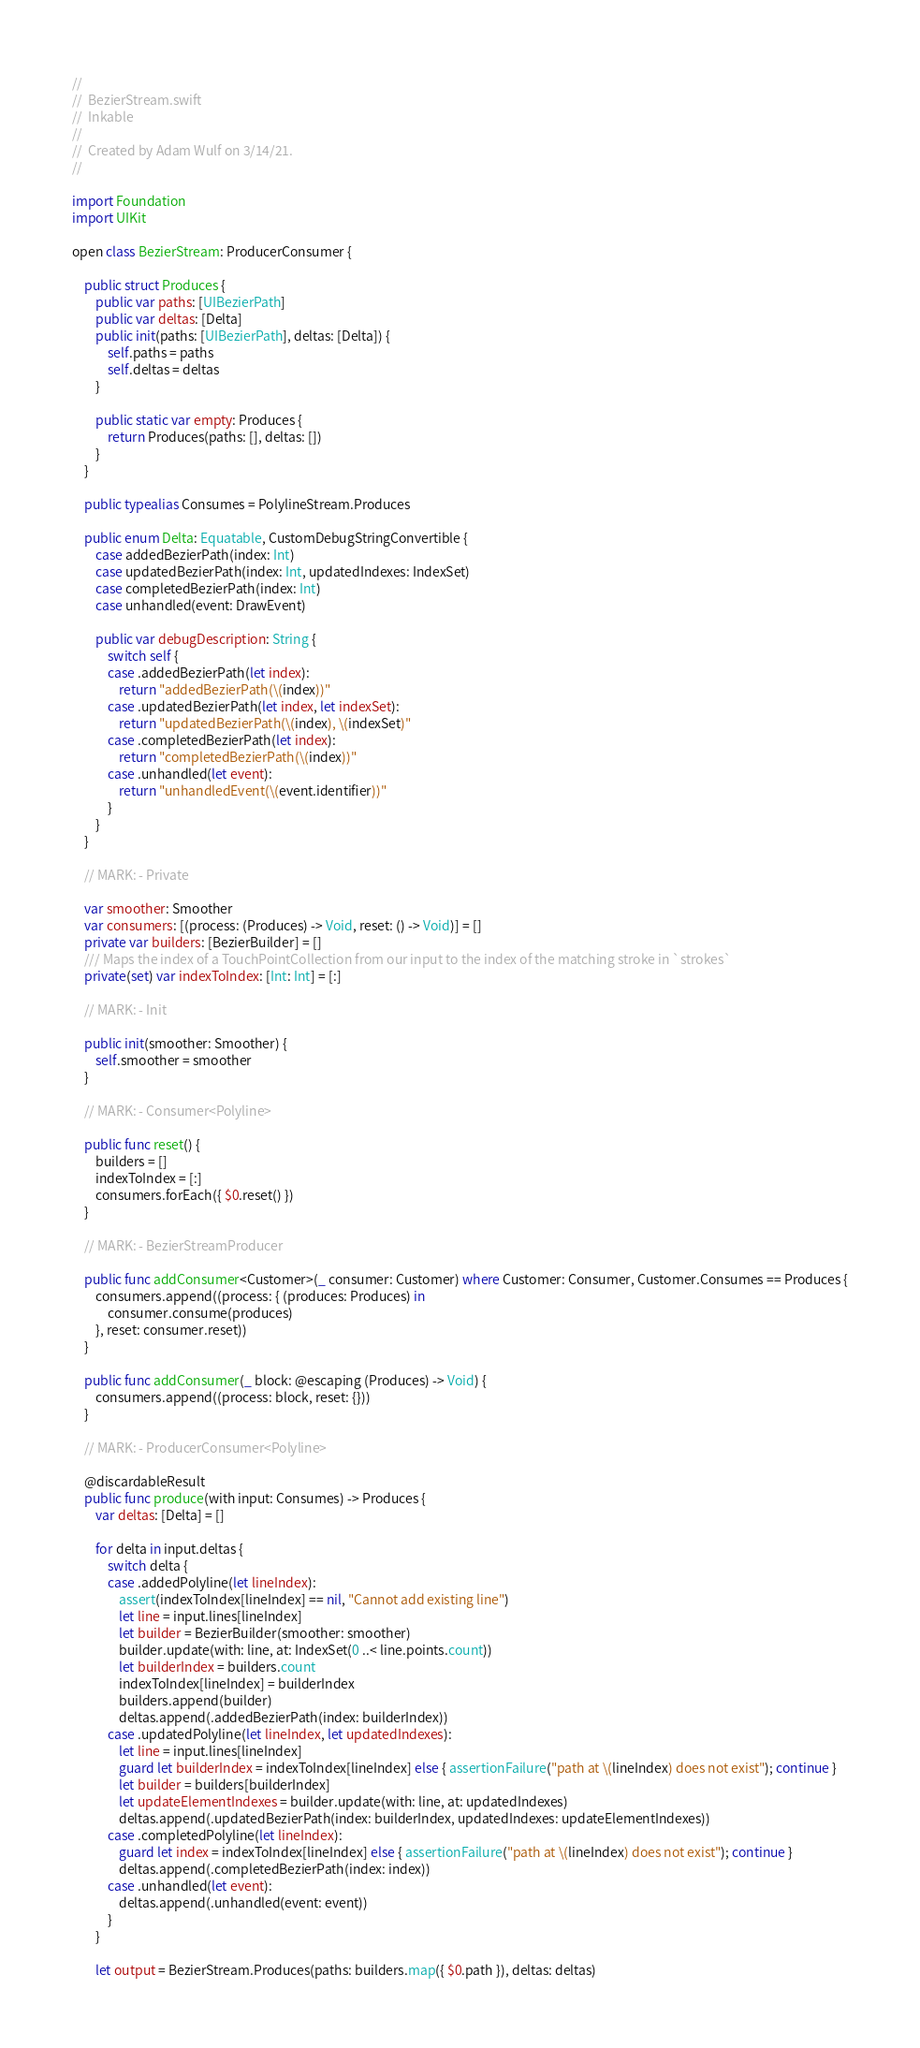<code> <loc_0><loc_0><loc_500><loc_500><_Swift_>//
//  BezierStream.swift
//  Inkable
//
//  Created by Adam Wulf on 3/14/21.
//

import Foundation
import UIKit

open class BezierStream: ProducerConsumer {

    public struct Produces {
        public var paths: [UIBezierPath]
        public var deltas: [Delta]
        public init(paths: [UIBezierPath], deltas: [Delta]) {
            self.paths = paths
            self.deltas = deltas
        }

        public static var empty: Produces {
            return Produces(paths: [], deltas: [])
        }
    }

    public typealias Consumes = PolylineStream.Produces

    public enum Delta: Equatable, CustomDebugStringConvertible {
        case addedBezierPath(index: Int)
        case updatedBezierPath(index: Int, updatedIndexes: IndexSet)
        case completedBezierPath(index: Int)
        case unhandled(event: DrawEvent)

        public var debugDescription: String {
            switch self {
            case .addedBezierPath(let index):
                return "addedBezierPath(\(index))"
            case .updatedBezierPath(let index, let indexSet):
                return "updatedBezierPath(\(index), \(indexSet)"
            case .completedBezierPath(let index):
                return "completedBezierPath(\(index))"
            case .unhandled(let event):
                return "unhandledEvent(\(event.identifier))"
            }
        }
    }

    // MARK: - Private

    var smoother: Smoother
    var consumers: [(process: (Produces) -> Void, reset: () -> Void)] = []
    private var builders: [BezierBuilder] = []
    /// Maps the index of a TouchPointCollection from our input to the index of the matching stroke in `strokes`
    private(set) var indexToIndex: [Int: Int] = [:]

    // MARK: - Init

    public init(smoother: Smoother) {
        self.smoother = smoother
    }

    // MARK: - Consumer<Polyline>

    public func reset() {
        builders = []
        indexToIndex = [:]
        consumers.forEach({ $0.reset() })
    }

    // MARK: - BezierStreamProducer

    public func addConsumer<Customer>(_ consumer: Customer) where Customer: Consumer, Customer.Consumes == Produces {
        consumers.append((process: { (produces: Produces) in
            consumer.consume(produces)
        }, reset: consumer.reset))
    }

    public func addConsumer(_ block: @escaping (Produces) -> Void) {
        consumers.append((process: block, reset: {}))
    }

    // MARK: - ProducerConsumer<Polyline>

    @discardableResult
    public func produce(with input: Consumes) -> Produces {
        var deltas: [Delta] = []

        for delta in input.deltas {
            switch delta {
            case .addedPolyline(let lineIndex):
                assert(indexToIndex[lineIndex] == nil, "Cannot add existing line")
                let line = input.lines[lineIndex]
                let builder = BezierBuilder(smoother: smoother)
                builder.update(with: line, at: IndexSet(0 ..< line.points.count))
                let builderIndex = builders.count
                indexToIndex[lineIndex] = builderIndex
                builders.append(builder)
                deltas.append(.addedBezierPath(index: builderIndex))
            case .updatedPolyline(let lineIndex, let updatedIndexes):
                let line = input.lines[lineIndex]
                guard let builderIndex = indexToIndex[lineIndex] else { assertionFailure("path at \(lineIndex) does not exist"); continue }
                let builder = builders[builderIndex]
                let updateElementIndexes = builder.update(with: line, at: updatedIndexes)
                deltas.append(.updatedBezierPath(index: builderIndex, updatedIndexes: updateElementIndexes))
            case .completedPolyline(let lineIndex):
                guard let index = indexToIndex[lineIndex] else { assertionFailure("path at \(lineIndex) does not exist"); continue }
                deltas.append(.completedBezierPath(index: index))
            case .unhandled(let event):
                deltas.append(.unhandled(event: event))
            }
        }

        let output = BezierStream.Produces(paths: builders.map({ $0.path }), deltas: deltas)</code> 